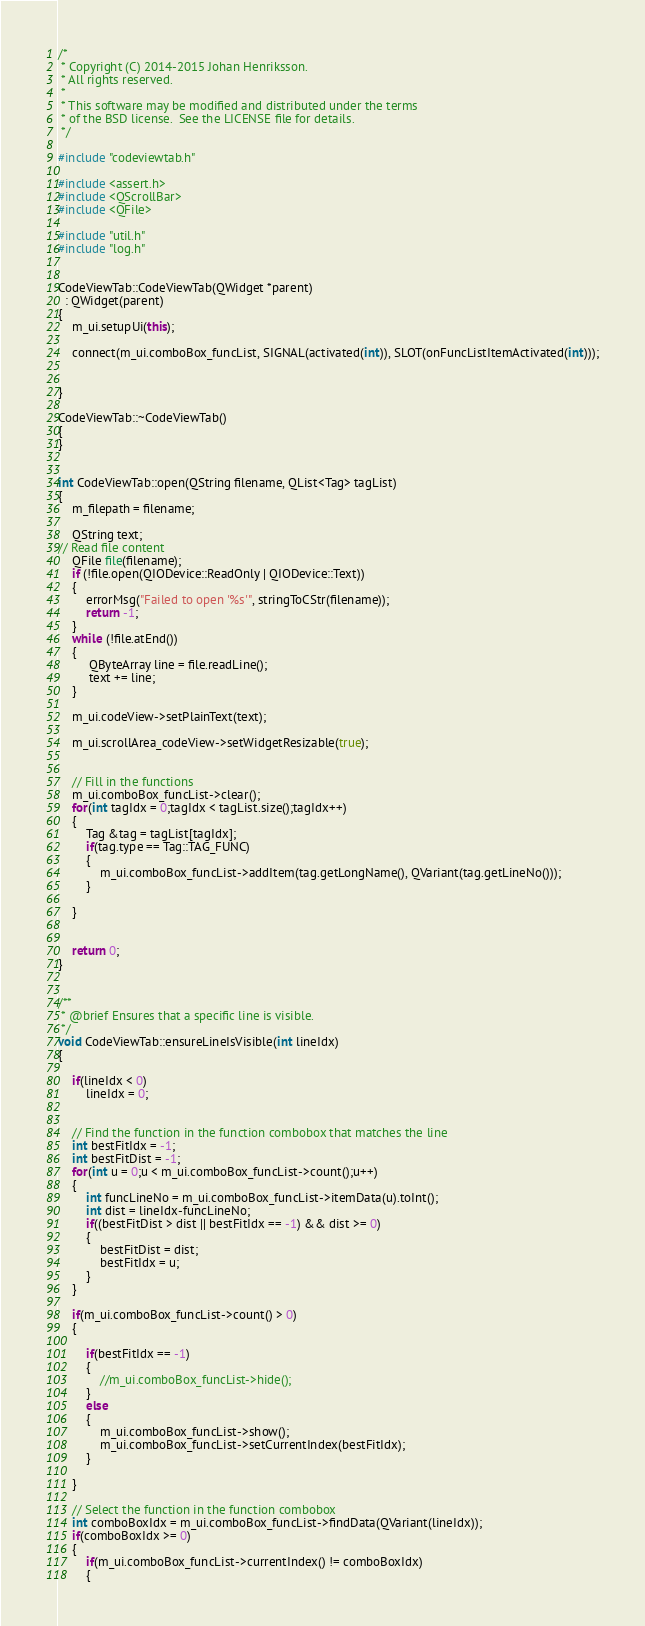Convert code to text. <code><loc_0><loc_0><loc_500><loc_500><_C++_>/*
 * Copyright (C) 2014-2015 Johan Henriksson.
 * All rights reserved.
 *
 * This software may be modified and distributed under the terms
 * of the BSD license.  See the LICENSE file for details.
 */

#include "codeviewtab.h"

#include <assert.h>
#include <QScrollBar>
#include <QFile>

#include "util.h"
#include "log.h"


CodeViewTab::CodeViewTab(QWidget *parent)
  : QWidget(parent)
{
    m_ui.setupUi(this);

    connect(m_ui.comboBox_funcList, SIGNAL(activated(int)), SLOT(onFuncListItemActivated(int)));

    
}

CodeViewTab::~CodeViewTab()
{
}


int CodeViewTab::open(QString filename, QList<Tag> tagList)
{
    m_filepath = filename;
    
    QString text;
// Read file content
    QFile file(filename);
    if (!file.open(QIODevice::ReadOnly | QIODevice::Text))
    {
        errorMsg("Failed to open '%s'", stringToCStr(filename));
        return -1;
    }
    while (!file.atEnd())
    {
         QByteArray line = file.readLine();
         text += line;
    }

    m_ui.codeView->setPlainText(text);

    m_ui.scrollArea_codeView->setWidgetResizable(true);


    // Fill in the functions
    m_ui.comboBox_funcList->clear();
    for(int tagIdx = 0;tagIdx < tagList.size();tagIdx++)
    {
        Tag &tag = tagList[tagIdx];
        if(tag.type == Tag::TAG_FUNC)
        {
            m_ui.comboBox_funcList->addItem(tag.getLongName(), QVariant(tag.getLineNo()));
        }
        
    }


    return 0;
}


/**
 * @brief Ensures that a specific line is visible.
 */
void CodeViewTab::ensureLineIsVisible(int lineIdx)
{
    
    if(lineIdx < 0)
        lineIdx = 0;


    // Find the function in the function combobox that matches the line
    int bestFitIdx = -1;
    int bestFitDist = -1;
    for(int u = 0;u < m_ui.comboBox_funcList->count();u++)
    {
        int funcLineNo = m_ui.comboBox_funcList->itemData(u).toInt();
        int dist = lineIdx-funcLineNo;
        if((bestFitDist > dist || bestFitIdx == -1) && dist >= 0)
        {
            bestFitDist = dist;
            bestFitIdx = u;
        }
    }

    if(m_ui.comboBox_funcList->count() > 0)
    {

        if(bestFitIdx == -1)
        {
            //m_ui.comboBox_funcList->hide();
        }
        else
        {
            m_ui.comboBox_funcList->show();
            m_ui.comboBox_funcList->setCurrentIndex(bestFitIdx);
        }

    }

    // Select the function in the function combobox
    int comboBoxIdx = m_ui.comboBox_funcList->findData(QVariant(lineIdx));
    if(comboBoxIdx >= 0)
    {
        if(m_ui.comboBox_funcList->currentIndex() != comboBoxIdx)
        {</code> 